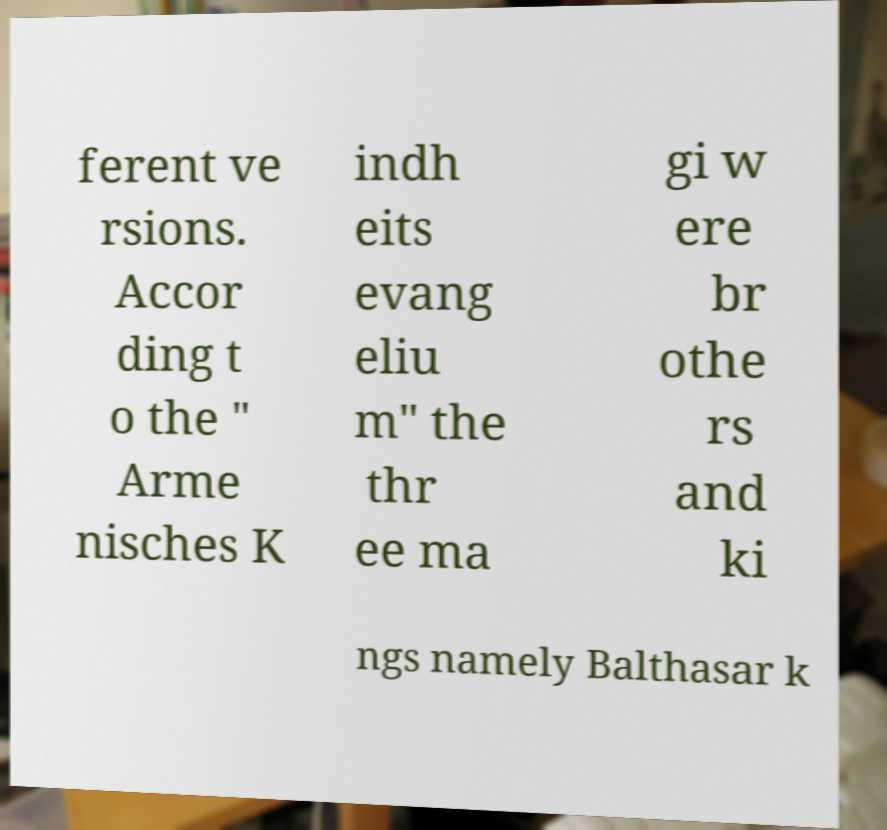Could you extract and type out the text from this image? ferent ve rsions. Accor ding t o the " Arme nisches K indh eits evang eliu m" the thr ee ma gi w ere br othe rs and ki ngs namely Balthasar k 